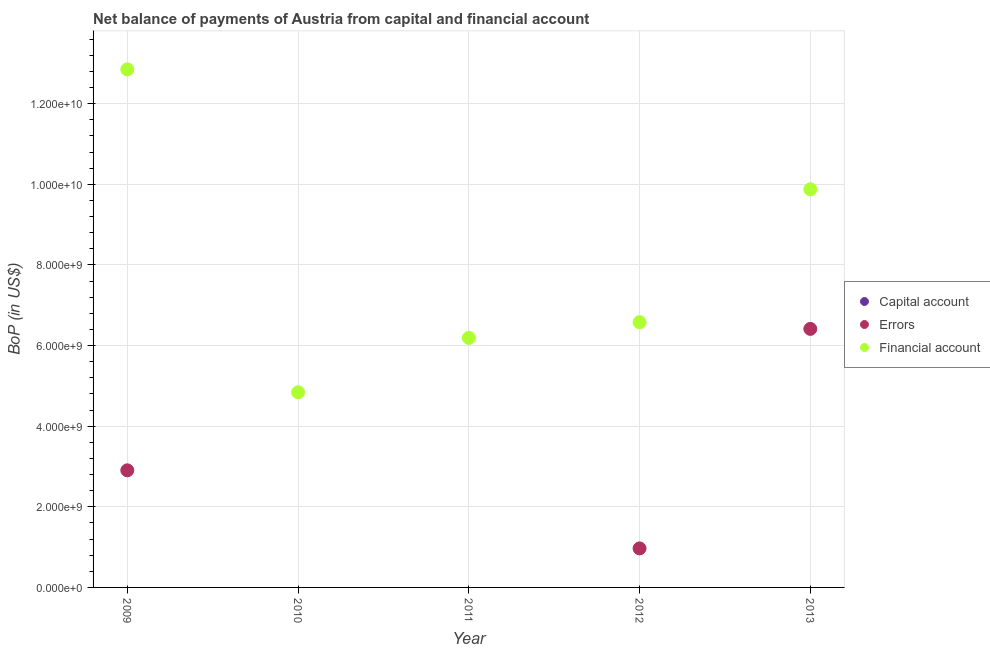How many different coloured dotlines are there?
Your response must be concise. 2. Is the number of dotlines equal to the number of legend labels?
Ensure brevity in your answer.  No. What is the amount of net capital account in 2010?
Provide a short and direct response. 0. Across all years, what is the maximum amount of errors?
Offer a terse response. 6.41e+09. Across all years, what is the minimum amount of errors?
Offer a terse response. 0. What is the total amount of errors in the graph?
Offer a very short reply. 1.03e+1. What is the difference between the amount of financial account in 2009 and that in 2013?
Make the answer very short. 2.98e+09. What is the difference between the amount of net capital account in 2011 and the amount of errors in 2013?
Give a very brief answer. -6.41e+09. What is the average amount of financial account per year?
Offer a terse response. 8.07e+09. What is the ratio of the amount of errors in 2009 to that in 2012?
Ensure brevity in your answer.  3. What is the difference between the highest and the second highest amount of errors?
Provide a short and direct response. 3.51e+09. What is the difference between the highest and the lowest amount of financial account?
Keep it short and to the point. 8.01e+09. In how many years, is the amount of errors greater than the average amount of errors taken over all years?
Your response must be concise. 2. Is the sum of the amount of financial account in 2010 and 2011 greater than the maximum amount of errors across all years?
Offer a terse response. Yes. How many dotlines are there?
Your response must be concise. 2. How many years are there in the graph?
Provide a short and direct response. 5. What is the difference between two consecutive major ticks on the Y-axis?
Give a very brief answer. 2.00e+09. Does the graph contain grids?
Provide a succinct answer. Yes. Where does the legend appear in the graph?
Keep it short and to the point. Center right. How many legend labels are there?
Your answer should be very brief. 3. How are the legend labels stacked?
Keep it short and to the point. Vertical. What is the title of the graph?
Make the answer very short. Net balance of payments of Austria from capital and financial account. What is the label or title of the Y-axis?
Your answer should be very brief. BoP (in US$). What is the BoP (in US$) in Capital account in 2009?
Provide a succinct answer. 0. What is the BoP (in US$) of Errors in 2009?
Keep it short and to the point. 2.91e+09. What is the BoP (in US$) in Financial account in 2009?
Give a very brief answer. 1.29e+1. What is the BoP (in US$) of Capital account in 2010?
Keep it short and to the point. 0. What is the BoP (in US$) of Financial account in 2010?
Give a very brief answer. 4.84e+09. What is the BoP (in US$) in Errors in 2011?
Keep it short and to the point. 0. What is the BoP (in US$) of Financial account in 2011?
Your response must be concise. 6.19e+09. What is the BoP (in US$) of Capital account in 2012?
Offer a terse response. 0. What is the BoP (in US$) of Errors in 2012?
Keep it short and to the point. 9.69e+08. What is the BoP (in US$) in Financial account in 2012?
Make the answer very short. 6.58e+09. What is the BoP (in US$) of Errors in 2013?
Your answer should be compact. 6.41e+09. What is the BoP (in US$) of Financial account in 2013?
Ensure brevity in your answer.  9.88e+09. Across all years, what is the maximum BoP (in US$) of Errors?
Your response must be concise. 6.41e+09. Across all years, what is the maximum BoP (in US$) in Financial account?
Offer a very short reply. 1.29e+1. Across all years, what is the minimum BoP (in US$) of Errors?
Your answer should be very brief. 0. Across all years, what is the minimum BoP (in US$) in Financial account?
Your answer should be very brief. 4.84e+09. What is the total BoP (in US$) in Errors in the graph?
Keep it short and to the point. 1.03e+1. What is the total BoP (in US$) in Financial account in the graph?
Ensure brevity in your answer.  4.03e+1. What is the difference between the BoP (in US$) of Financial account in 2009 and that in 2010?
Provide a short and direct response. 8.01e+09. What is the difference between the BoP (in US$) in Financial account in 2009 and that in 2011?
Ensure brevity in your answer.  6.66e+09. What is the difference between the BoP (in US$) of Errors in 2009 and that in 2012?
Provide a short and direct response. 1.94e+09. What is the difference between the BoP (in US$) of Financial account in 2009 and that in 2012?
Give a very brief answer. 6.27e+09. What is the difference between the BoP (in US$) of Errors in 2009 and that in 2013?
Ensure brevity in your answer.  -3.51e+09. What is the difference between the BoP (in US$) of Financial account in 2009 and that in 2013?
Provide a short and direct response. 2.98e+09. What is the difference between the BoP (in US$) in Financial account in 2010 and that in 2011?
Keep it short and to the point. -1.35e+09. What is the difference between the BoP (in US$) of Financial account in 2010 and that in 2012?
Your answer should be very brief. -1.74e+09. What is the difference between the BoP (in US$) in Financial account in 2010 and that in 2013?
Offer a very short reply. -5.04e+09. What is the difference between the BoP (in US$) of Financial account in 2011 and that in 2012?
Your answer should be very brief. -3.90e+08. What is the difference between the BoP (in US$) of Financial account in 2011 and that in 2013?
Your response must be concise. -3.69e+09. What is the difference between the BoP (in US$) in Errors in 2012 and that in 2013?
Offer a terse response. -5.45e+09. What is the difference between the BoP (in US$) in Financial account in 2012 and that in 2013?
Your answer should be compact. -3.30e+09. What is the difference between the BoP (in US$) of Errors in 2009 and the BoP (in US$) of Financial account in 2010?
Offer a very short reply. -1.94e+09. What is the difference between the BoP (in US$) of Errors in 2009 and the BoP (in US$) of Financial account in 2011?
Provide a succinct answer. -3.28e+09. What is the difference between the BoP (in US$) of Errors in 2009 and the BoP (in US$) of Financial account in 2012?
Your answer should be very brief. -3.68e+09. What is the difference between the BoP (in US$) in Errors in 2009 and the BoP (in US$) in Financial account in 2013?
Your answer should be compact. -6.97e+09. What is the difference between the BoP (in US$) in Errors in 2012 and the BoP (in US$) in Financial account in 2013?
Give a very brief answer. -8.91e+09. What is the average BoP (in US$) in Capital account per year?
Give a very brief answer. 0. What is the average BoP (in US$) of Errors per year?
Offer a very short reply. 2.06e+09. What is the average BoP (in US$) in Financial account per year?
Provide a succinct answer. 8.07e+09. In the year 2009, what is the difference between the BoP (in US$) of Errors and BoP (in US$) of Financial account?
Your response must be concise. -9.95e+09. In the year 2012, what is the difference between the BoP (in US$) of Errors and BoP (in US$) of Financial account?
Provide a short and direct response. -5.61e+09. In the year 2013, what is the difference between the BoP (in US$) of Errors and BoP (in US$) of Financial account?
Offer a terse response. -3.46e+09. What is the ratio of the BoP (in US$) of Financial account in 2009 to that in 2010?
Ensure brevity in your answer.  2.65. What is the ratio of the BoP (in US$) in Financial account in 2009 to that in 2011?
Offer a very short reply. 2.08. What is the ratio of the BoP (in US$) of Errors in 2009 to that in 2012?
Your answer should be very brief. 3. What is the ratio of the BoP (in US$) in Financial account in 2009 to that in 2012?
Keep it short and to the point. 1.95. What is the ratio of the BoP (in US$) in Errors in 2009 to that in 2013?
Offer a terse response. 0.45. What is the ratio of the BoP (in US$) of Financial account in 2009 to that in 2013?
Give a very brief answer. 1.3. What is the ratio of the BoP (in US$) of Financial account in 2010 to that in 2011?
Provide a succinct answer. 0.78. What is the ratio of the BoP (in US$) of Financial account in 2010 to that in 2012?
Ensure brevity in your answer.  0.74. What is the ratio of the BoP (in US$) in Financial account in 2010 to that in 2013?
Give a very brief answer. 0.49. What is the ratio of the BoP (in US$) in Financial account in 2011 to that in 2012?
Provide a short and direct response. 0.94. What is the ratio of the BoP (in US$) in Financial account in 2011 to that in 2013?
Your answer should be very brief. 0.63. What is the ratio of the BoP (in US$) in Errors in 2012 to that in 2013?
Your answer should be compact. 0.15. What is the ratio of the BoP (in US$) of Financial account in 2012 to that in 2013?
Your answer should be very brief. 0.67. What is the difference between the highest and the second highest BoP (in US$) in Errors?
Your response must be concise. 3.51e+09. What is the difference between the highest and the second highest BoP (in US$) of Financial account?
Ensure brevity in your answer.  2.98e+09. What is the difference between the highest and the lowest BoP (in US$) in Errors?
Your response must be concise. 6.41e+09. What is the difference between the highest and the lowest BoP (in US$) in Financial account?
Offer a terse response. 8.01e+09. 